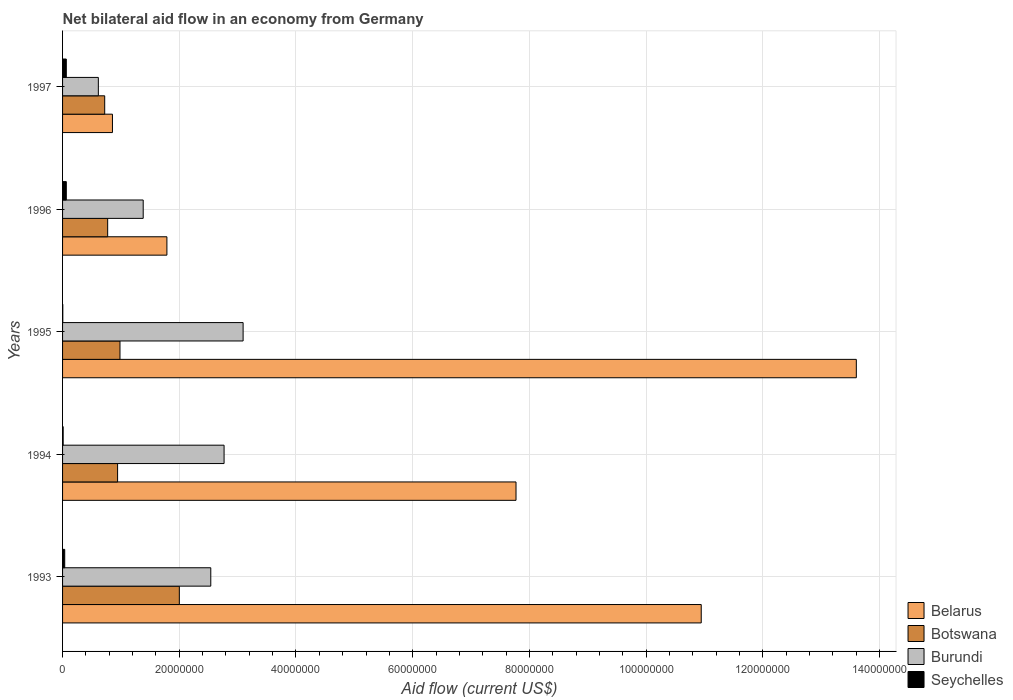How many different coloured bars are there?
Make the answer very short. 4. How many groups of bars are there?
Offer a terse response. 5. Are the number of bars on each tick of the Y-axis equal?
Offer a terse response. Yes. How many bars are there on the 5th tick from the top?
Make the answer very short. 4. In how many cases, is the number of bars for a given year not equal to the number of legend labels?
Give a very brief answer. 0. What is the net bilateral aid flow in Burundi in 1997?
Provide a short and direct response. 6.13e+06. Across all years, what is the maximum net bilateral aid flow in Belarus?
Offer a terse response. 1.36e+08. In which year was the net bilateral aid flow in Botswana minimum?
Give a very brief answer. 1997. What is the total net bilateral aid flow in Burundi in the graph?
Your answer should be compact. 1.04e+08. What is the difference between the net bilateral aid flow in Burundi in 1994 and the net bilateral aid flow in Seychelles in 1995?
Provide a succinct answer. 2.76e+07. What is the average net bilateral aid flow in Belarus per year?
Keep it short and to the point. 6.99e+07. In the year 1997, what is the difference between the net bilateral aid flow in Botswana and net bilateral aid flow in Seychelles?
Your answer should be very brief. 6.58e+06. What is the ratio of the net bilateral aid flow in Botswana in 1994 to that in 1996?
Your answer should be compact. 1.22. What is the difference between the highest and the second highest net bilateral aid flow in Belarus?
Your answer should be very brief. 2.66e+07. What is the difference between the highest and the lowest net bilateral aid flow in Botswana?
Ensure brevity in your answer.  1.28e+07. In how many years, is the net bilateral aid flow in Botswana greater than the average net bilateral aid flow in Botswana taken over all years?
Your response must be concise. 1. What does the 4th bar from the top in 1994 represents?
Give a very brief answer. Belarus. What does the 1st bar from the bottom in 1996 represents?
Give a very brief answer. Belarus. Are all the bars in the graph horizontal?
Offer a very short reply. Yes. Are the values on the major ticks of X-axis written in scientific E-notation?
Ensure brevity in your answer.  No. Does the graph contain any zero values?
Offer a very short reply. No. Does the graph contain grids?
Your answer should be very brief. Yes. How many legend labels are there?
Make the answer very short. 4. What is the title of the graph?
Your response must be concise. Net bilateral aid flow in an economy from Germany. Does "Turks and Caicos Islands" appear as one of the legend labels in the graph?
Your response must be concise. No. What is the Aid flow (current US$) of Belarus in 1993?
Your response must be concise. 1.09e+08. What is the Aid flow (current US$) in Botswana in 1993?
Provide a short and direct response. 2.00e+07. What is the Aid flow (current US$) of Burundi in 1993?
Provide a short and direct response. 2.54e+07. What is the Aid flow (current US$) in Belarus in 1994?
Provide a short and direct response. 7.77e+07. What is the Aid flow (current US$) in Botswana in 1994?
Give a very brief answer. 9.43e+06. What is the Aid flow (current US$) of Burundi in 1994?
Give a very brief answer. 2.77e+07. What is the Aid flow (current US$) of Seychelles in 1994?
Keep it short and to the point. 1.00e+05. What is the Aid flow (current US$) in Belarus in 1995?
Your answer should be compact. 1.36e+08. What is the Aid flow (current US$) of Botswana in 1995?
Provide a short and direct response. 9.84e+06. What is the Aid flow (current US$) of Burundi in 1995?
Keep it short and to the point. 3.09e+07. What is the Aid flow (current US$) of Belarus in 1996?
Keep it short and to the point. 1.79e+07. What is the Aid flow (current US$) in Botswana in 1996?
Ensure brevity in your answer.  7.73e+06. What is the Aid flow (current US$) of Burundi in 1996?
Keep it short and to the point. 1.38e+07. What is the Aid flow (current US$) of Seychelles in 1996?
Offer a terse response. 6.40e+05. What is the Aid flow (current US$) of Belarus in 1997?
Your response must be concise. 8.55e+06. What is the Aid flow (current US$) in Botswana in 1997?
Offer a terse response. 7.22e+06. What is the Aid flow (current US$) in Burundi in 1997?
Give a very brief answer. 6.13e+06. What is the Aid flow (current US$) in Seychelles in 1997?
Provide a short and direct response. 6.40e+05. Across all years, what is the maximum Aid flow (current US$) of Belarus?
Offer a terse response. 1.36e+08. Across all years, what is the maximum Aid flow (current US$) of Botswana?
Provide a short and direct response. 2.00e+07. Across all years, what is the maximum Aid flow (current US$) in Burundi?
Give a very brief answer. 3.09e+07. Across all years, what is the maximum Aid flow (current US$) of Seychelles?
Provide a succinct answer. 6.40e+05. Across all years, what is the minimum Aid flow (current US$) in Belarus?
Your answer should be compact. 8.55e+06. Across all years, what is the minimum Aid flow (current US$) of Botswana?
Your answer should be very brief. 7.22e+06. Across all years, what is the minimum Aid flow (current US$) of Burundi?
Ensure brevity in your answer.  6.13e+06. Across all years, what is the minimum Aid flow (current US$) in Seychelles?
Ensure brevity in your answer.  4.00e+04. What is the total Aid flow (current US$) in Belarus in the graph?
Give a very brief answer. 3.50e+08. What is the total Aid flow (current US$) of Botswana in the graph?
Provide a short and direct response. 5.42e+07. What is the total Aid flow (current US$) of Burundi in the graph?
Offer a very short reply. 1.04e+08. What is the total Aid flow (current US$) of Seychelles in the graph?
Your response must be concise. 1.79e+06. What is the difference between the Aid flow (current US$) of Belarus in 1993 and that in 1994?
Keep it short and to the point. 3.17e+07. What is the difference between the Aid flow (current US$) in Botswana in 1993 and that in 1994?
Offer a terse response. 1.06e+07. What is the difference between the Aid flow (current US$) in Burundi in 1993 and that in 1994?
Offer a very short reply. -2.28e+06. What is the difference between the Aid flow (current US$) in Belarus in 1993 and that in 1995?
Offer a very short reply. -2.66e+07. What is the difference between the Aid flow (current US$) of Botswana in 1993 and that in 1995?
Give a very brief answer. 1.02e+07. What is the difference between the Aid flow (current US$) in Burundi in 1993 and that in 1995?
Your response must be concise. -5.54e+06. What is the difference between the Aid flow (current US$) in Seychelles in 1993 and that in 1995?
Provide a short and direct response. 3.30e+05. What is the difference between the Aid flow (current US$) in Belarus in 1993 and that in 1996?
Keep it short and to the point. 9.16e+07. What is the difference between the Aid flow (current US$) in Botswana in 1993 and that in 1996?
Your response must be concise. 1.23e+07. What is the difference between the Aid flow (current US$) of Burundi in 1993 and that in 1996?
Your answer should be very brief. 1.16e+07. What is the difference between the Aid flow (current US$) of Seychelles in 1993 and that in 1996?
Your response must be concise. -2.70e+05. What is the difference between the Aid flow (current US$) in Belarus in 1993 and that in 1997?
Make the answer very short. 1.01e+08. What is the difference between the Aid flow (current US$) in Botswana in 1993 and that in 1997?
Keep it short and to the point. 1.28e+07. What is the difference between the Aid flow (current US$) of Burundi in 1993 and that in 1997?
Your answer should be compact. 1.93e+07. What is the difference between the Aid flow (current US$) in Seychelles in 1993 and that in 1997?
Your answer should be compact. -2.70e+05. What is the difference between the Aid flow (current US$) of Belarus in 1994 and that in 1995?
Provide a short and direct response. -5.83e+07. What is the difference between the Aid flow (current US$) in Botswana in 1994 and that in 1995?
Keep it short and to the point. -4.10e+05. What is the difference between the Aid flow (current US$) in Burundi in 1994 and that in 1995?
Provide a succinct answer. -3.26e+06. What is the difference between the Aid flow (current US$) in Belarus in 1994 and that in 1996?
Keep it short and to the point. 5.98e+07. What is the difference between the Aid flow (current US$) of Botswana in 1994 and that in 1996?
Ensure brevity in your answer.  1.70e+06. What is the difference between the Aid flow (current US$) of Burundi in 1994 and that in 1996?
Provide a short and direct response. 1.39e+07. What is the difference between the Aid flow (current US$) in Seychelles in 1994 and that in 1996?
Your answer should be compact. -5.40e+05. What is the difference between the Aid flow (current US$) of Belarus in 1994 and that in 1997?
Your answer should be very brief. 6.92e+07. What is the difference between the Aid flow (current US$) of Botswana in 1994 and that in 1997?
Offer a very short reply. 2.21e+06. What is the difference between the Aid flow (current US$) in Burundi in 1994 and that in 1997?
Your response must be concise. 2.16e+07. What is the difference between the Aid flow (current US$) in Seychelles in 1994 and that in 1997?
Give a very brief answer. -5.40e+05. What is the difference between the Aid flow (current US$) in Belarus in 1995 and that in 1996?
Your answer should be compact. 1.18e+08. What is the difference between the Aid flow (current US$) of Botswana in 1995 and that in 1996?
Give a very brief answer. 2.11e+06. What is the difference between the Aid flow (current US$) in Burundi in 1995 and that in 1996?
Provide a succinct answer. 1.71e+07. What is the difference between the Aid flow (current US$) in Seychelles in 1995 and that in 1996?
Provide a succinct answer. -6.00e+05. What is the difference between the Aid flow (current US$) of Belarus in 1995 and that in 1997?
Offer a terse response. 1.27e+08. What is the difference between the Aid flow (current US$) of Botswana in 1995 and that in 1997?
Give a very brief answer. 2.62e+06. What is the difference between the Aid flow (current US$) of Burundi in 1995 and that in 1997?
Keep it short and to the point. 2.48e+07. What is the difference between the Aid flow (current US$) in Seychelles in 1995 and that in 1997?
Offer a very short reply. -6.00e+05. What is the difference between the Aid flow (current US$) in Belarus in 1996 and that in 1997?
Your answer should be very brief. 9.33e+06. What is the difference between the Aid flow (current US$) of Botswana in 1996 and that in 1997?
Your answer should be very brief. 5.10e+05. What is the difference between the Aid flow (current US$) in Burundi in 1996 and that in 1997?
Offer a terse response. 7.69e+06. What is the difference between the Aid flow (current US$) of Seychelles in 1996 and that in 1997?
Keep it short and to the point. 0. What is the difference between the Aid flow (current US$) in Belarus in 1993 and the Aid flow (current US$) in Botswana in 1994?
Your response must be concise. 1.00e+08. What is the difference between the Aid flow (current US$) in Belarus in 1993 and the Aid flow (current US$) in Burundi in 1994?
Provide a short and direct response. 8.18e+07. What is the difference between the Aid flow (current US$) of Belarus in 1993 and the Aid flow (current US$) of Seychelles in 1994?
Your answer should be very brief. 1.09e+08. What is the difference between the Aid flow (current US$) in Botswana in 1993 and the Aid flow (current US$) in Burundi in 1994?
Keep it short and to the point. -7.67e+06. What is the difference between the Aid flow (current US$) in Botswana in 1993 and the Aid flow (current US$) in Seychelles in 1994?
Provide a succinct answer. 1.99e+07. What is the difference between the Aid flow (current US$) in Burundi in 1993 and the Aid flow (current US$) in Seychelles in 1994?
Make the answer very short. 2.53e+07. What is the difference between the Aid flow (current US$) in Belarus in 1993 and the Aid flow (current US$) in Botswana in 1995?
Give a very brief answer. 9.96e+07. What is the difference between the Aid flow (current US$) of Belarus in 1993 and the Aid flow (current US$) of Burundi in 1995?
Offer a very short reply. 7.85e+07. What is the difference between the Aid flow (current US$) of Belarus in 1993 and the Aid flow (current US$) of Seychelles in 1995?
Your answer should be compact. 1.09e+08. What is the difference between the Aid flow (current US$) of Botswana in 1993 and the Aid flow (current US$) of Burundi in 1995?
Keep it short and to the point. -1.09e+07. What is the difference between the Aid flow (current US$) of Botswana in 1993 and the Aid flow (current US$) of Seychelles in 1995?
Make the answer very short. 2.00e+07. What is the difference between the Aid flow (current US$) in Burundi in 1993 and the Aid flow (current US$) in Seychelles in 1995?
Provide a succinct answer. 2.54e+07. What is the difference between the Aid flow (current US$) in Belarus in 1993 and the Aid flow (current US$) in Botswana in 1996?
Make the answer very short. 1.02e+08. What is the difference between the Aid flow (current US$) in Belarus in 1993 and the Aid flow (current US$) in Burundi in 1996?
Offer a very short reply. 9.56e+07. What is the difference between the Aid flow (current US$) in Belarus in 1993 and the Aid flow (current US$) in Seychelles in 1996?
Give a very brief answer. 1.09e+08. What is the difference between the Aid flow (current US$) in Botswana in 1993 and the Aid flow (current US$) in Burundi in 1996?
Keep it short and to the point. 6.19e+06. What is the difference between the Aid flow (current US$) of Botswana in 1993 and the Aid flow (current US$) of Seychelles in 1996?
Your response must be concise. 1.94e+07. What is the difference between the Aid flow (current US$) in Burundi in 1993 and the Aid flow (current US$) in Seychelles in 1996?
Give a very brief answer. 2.48e+07. What is the difference between the Aid flow (current US$) of Belarus in 1993 and the Aid flow (current US$) of Botswana in 1997?
Make the answer very short. 1.02e+08. What is the difference between the Aid flow (current US$) of Belarus in 1993 and the Aid flow (current US$) of Burundi in 1997?
Your answer should be very brief. 1.03e+08. What is the difference between the Aid flow (current US$) in Belarus in 1993 and the Aid flow (current US$) in Seychelles in 1997?
Offer a very short reply. 1.09e+08. What is the difference between the Aid flow (current US$) in Botswana in 1993 and the Aid flow (current US$) in Burundi in 1997?
Your answer should be very brief. 1.39e+07. What is the difference between the Aid flow (current US$) of Botswana in 1993 and the Aid flow (current US$) of Seychelles in 1997?
Your answer should be compact. 1.94e+07. What is the difference between the Aid flow (current US$) of Burundi in 1993 and the Aid flow (current US$) of Seychelles in 1997?
Keep it short and to the point. 2.48e+07. What is the difference between the Aid flow (current US$) of Belarus in 1994 and the Aid flow (current US$) of Botswana in 1995?
Provide a short and direct response. 6.79e+07. What is the difference between the Aid flow (current US$) in Belarus in 1994 and the Aid flow (current US$) in Burundi in 1995?
Your answer should be compact. 4.68e+07. What is the difference between the Aid flow (current US$) in Belarus in 1994 and the Aid flow (current US$) in Seychelles in 1995?
Provide a short and direct response. 7.77e+07. What is the difference between the Aid flow (current US$) of Botswana in 1994 and the Aid flow (current US$) of Burundi in 1995?
Offer a terse response. -2.15e+07. What is the difference between the Aid flow (current US$) of Botswana in 1994 and the Aid flow (current US$) of Seychelles in 1995?
Provide a short and direct response. 9.39e+06. What is the difference between the Aid flow (current US$) in Burundi in 1994 and the Aid flow (current US$) in Seychelles in 1995?
Keep it short and to the point. 2.76e+07. What is the difference between the Aid flow (current US$) in Belarus in 1994 and the Aid flow (current US$) in Botswana in 1996?
Your answer should be compact. 7.00e+07. What is the difference between the Aid flow (current US$) in Belarus in 1994 and the Aid flow (current US$) in Burundi in 1996?
Your answer should be compact. 6.39e+07. What is the difference between the Aid flow (current US$) of Belarus in 1994 and the Aid flow (current US$) of Seychelles in 1996?
Offer a terse response. 7.71e+07. What is the difference between the Aid flow (current US$) of Botswana in 1994 and the Aid flow (current US$) of Burundi in 1996?
Ensure brevity in your answer.  -4.39e+06. What is the difference between the Aid flow (current US$) in Botswana in 1994 and the Aid flow (current US$) in Seychelles in 1996?
Keep it short and to the point. 8.79e+06. What is the difference between the Aid flow (current US$) of Burundi in 1994 and the Aid flow (current US$) of Seychelles in 1996?
Give a very brief answer. 2.70e+07. What is the difference between the Aid flow (current US$) of Belarus in 1994 and the Aid flow (current US$) of Botswana in 1997?
Provide a short and direct response. 7.05e+07. What is the difference between the Aid flow (current US$) in Belarus in 1994 and the Aid flow (current US$) in Burundi in 1997?
Your answer should be compact. 7.16e+07. What is the difference between the Aid flow (current US$) in Belarus in 1994 and the Aid flow (current US$) in Seychelles in 1997?
Offer a terse response. 7.71e+07. What is the difference between the Aid flow (current US$) of Botswana in 1994 and the Aid flow (current US$) of Burundi in 1997?
Your response must be concise. 3.30e+06. What is the difference between the Aid flow (current US$) of Botswana in 1994 and the Aid flow (current US$) of Seychelles in 1997?
Offer a very short reply. 8.79e+06. What is the difference between the Aid flow (current US$) of Burundi in 1994 and the Aid flow (current US$) of Seychelles in 1997?
Provide a short and direct response. 2.70e+07. What is the difference between the Aid flow (current US$) in Belarus in 1995 and the Aid flow (current US$) in Botswana in 1996?
Ensure brevity in your answer.  1.28e+08. What is the difference between the Aid flow (current US$) of Belarus in 1995 and the Aid flow (current US$) of Burundi in 1996?
Provide a succinct answer. 1.22e+08. What is the difference between the Aid flow (current US$) of Belarus in 1995 and the Aid flow (current US$) of Seychelles in 1996?
Offer a terse response. 1.35e+08. What is the difference between the Aid flow (current US$) of Botswana in 1995 and the Aid flow (current US$) of Burundi in 1996?
Offer a terse response. -3.98e+06. What is the difference between the Aid flow (current US$) in Botswana in 1995 and the Aid flow (current US$) in Seychelles in 1996?
Provide a succinct answer. 9.20e+06. What is the difference between the Aid flow (current US$) in Burundi in 1995 and the Aid flow (current US$) in Seychelles in 1996?
Your response must be concise. 3.03e+07. What is the difference between the Aid flow (current US$) in Belarus in 1995 and the Aid flow (current US$) in Botswana in 1997?
Ensure brevity in your answer.  1.29e+08. What is the difference between the Aid flow (current US$) of Belarus in 1995 and the Aid flow (current US$) of Burundi in 1997?
Offer a terse response. 1.30e+08. What is the difference between the Aid flow (current US$) of Belarus in 1995 and the Aid flow (current US$) of Seychelles in 1997?
Your answer should be very brief. 1.35e+08. What is the difference between the Aid flow (current US$) of Botswana in 1995 and the Aid flow (current US$) of Burundi in 1997?
Ensure brevity in your answer.  3.71e+06. What is the difference between the Aid flow (current US$) of Botswana in 1995 and the Aid flow (current US$) of Seychelles in 1997?
Offer a very short reply. 9.20e+06. What is the difference between the Aid flow (current US$) in Burundi in 1995 and the Aid flow (current US$) in Seychelles in 1997?
Give a very brief answer. 3.03e+07. What is the difference between the Aid flow (current US$) of Belarus in 1996 and the Aid flow (current US$) of Botswana in 1997?
Your answer should be very brief. 1.07e+07. What is the difference between the Aid flow (current US$) in Belarus in 1996 and the Aid flow (current US$) in Burundi in 1997?
Offer a very short reply. 1.18e+07. What is the difference between the Aid flow (current US$) of Belarus in 1996 and the Aid flow (current US$) of Seychelles in 1997?
Offer a very short reply. 1.72e+07. What is the difference between the Aid flow (current US$) in Botswana in 1996 and the Aid flow (current US$) in Burundi in 1997?
Keep it short and to the point. 1.60e+06. What is the difference between the Aid flow (current US$) in Botswana in 1996 and the Aid flow (current US$) in Seychelles in 1997?
Offer a very short reply. 7.09e+06. What is the difference between the Aid flow (current US$) of Burundi in 1996 and the Aid flow (current US$) of Seychelles in 1997?
Make the answer very short. 1.32e+07. What is the average Aid flow (current US$) of Belarus per year?
Give a very brief answer. 6.99e+07. What is the average Aid flow (current US$) of Botswana per year?
Your answer should be compact. 1.08e+07. What is the average Aid flow (current US$) of Burundi per year?
Make the answer very short. 2.08e+07. What is the average Aid flow (current US$) of Seychelles per year?
Your answer should be very brief. 3.58e+05. In the year 1993, what is the difference between the Aid flow (current US$) of Belarus and Aid flow (current US$) of Botswana?
Provide a succinct answer. 8.94e+07. In the year 1993, what is the difference between the Aid flow (current US$) of Belarus and Aid flow (current US$) of Burundi?
Offer a terse response. 8.40e+07. In the year 1993, what is the difference between the Aid flow (current US$) of Belarus and Aid flow (current US$) of Seychelles?
Your answer should be compact. 1.09e+08. In the year 1993, what is the difference between the Aid flow (current US$) of Botswana and Aid flow (current US$) of Burundi?
Keep it short and to the point. -5.39e+06. In the year 1993, what is the difference between the Aid flow (current US$) of Botswana and Aid flow (current US$) of Seychelles?
Make the answer very short. 1.96e+07. In the year 1993, what is the difference between the Aid flow (current US$) in Burundi and Aid flow (current US$) in Seychelles?
Make the answer very short. 2.50e+07. In the year 1994, what is the difference between the Aid flow (current US$) of Belarus and Aid flow (current US$) of Botswana?
Ensure brevity in your answer.  6.83e+07. In the year 1994, what is the difference between the Aid flow (current US$) in Belarus and Aid flow (current US$) in Burundi?
Keep it short and to the point. 5.00e+07. In the year 1994, what is the difference between the Aid flow (current US$) of Belarus and Aid flow (current US$) of Seychelles?
Keep it short and to the point. 7.76e+07. In the year 1994, what is the difference between the Aid flow (current US$) in Botswana and Aid flow (current US$) in Burundi?
Your response must be concise. -1.82e+07. In the year 1994, what is the difference between the Aid flow (current US$) in Botswana and Aid flow (current US$) in Seychelles?
Your answer should be very brief. 9.33e+06. In the year 1994, what is the difference between the Aid flow (current US$) in Burundi and Aid flow (current US$) in Seychelles?
Provide a short and direct response. 2.76e+07. In the year 1995, what is the difference between the Aid flow (current US$) of Belarus and Aid flow (current US$) of Botswana?
Offer a very short reply. 1.26e+08. In the year 1995, what is the difference between the Aid flow (current US$) in Belarus and Aid flow (current US$) in Burundi?
Keep it short and to the point. 1.05e+08. In the year 1995, what is the difference between the Aid flow (current US$) in Belarus and Aid flow (current US$) in Seychelles?
Offer a very short reply. 1.36e+08. In the year 1995, what is the difference between the Aid flow (current US$) of Botswana and Aid flow (current US$) of Burundi?
Give a very brief answer. -2.11e+07. In the year 1995, what is the difference between the Aid flow (current US$) of Botswana and Aid flow (current US$) of Seychelles?
Your response must be concise. 9.80e+06. In the year 1995, what is the difference between the Aid flow (current US$) in Burundi and Aid flow (current US$) in Seychelles?
Provide a short and direct response. 3.09e+07. In the year 1996, what is the difference between the Aid flow (current US$) of Belarus and Aid flow (current US$) of Botswana?
Give a very brief answer. 1.02e+07. In the year 1996, what is the difference between the Aid flow (current US$) of Belarus and Aid flow (current US$) of Burundi?
Give a very brief answer. 4.06e+06. In the year 1996, what is the difference between the Aid flow (current US$) of Belarus and Aid flow (current US$) of Seychelles?
Offer a very short reply. 1.72e+07. In the year 1996, what is the difference between the Aid flow (current US$) in Botswana and Aid flow (current US$) in Burundi?
Keep it short and to the point. -6.09e+06. In the year 1996, what is the difference between the Aid flow (current US$) of Botswana and Aid flow (current US$) of Seychelles?
Give a very brief answer. 7.09e+06. In the year 1996, what is the difference between the Aid flow (current US$) of Burundi and Aid flow (current US$) of Seychelles?
Offer a terse response. 1.32e+07. In the year 1997, what is the difference between the Aid flow (current US$) of Belarus and Aid flow (current US$) of Botswana?
Your answer should be compact. 1.33e+06. In the year 1997, what is the difference between the Aid flow (current US$) of Belarus and Aid flow (current US$) of Burundi?
Provide a short and direct response. 2.42e+06. In the year 1997, what is the difference between the Aid flow (current US$) of Belarus and Aid flow (current US$) of Seychelles?
Make the answer very short. 7.91e+06. In the year 1997, what is the difference between the Aid flow (current US$) of Botswana and Aid flow (current US$) of Burundi?
Provide a succinct answer. 1.09e+06. In the year 1997, what is the difference between the Aid flow (current US$) in Botswana and Aid flow (current US$) in Seychelles?
Offer a very short reply. 6.58e+06. In the year 1997, what is the difference between the Aid flow (current US$) of Burundi and Aid flow (current US$) of Seychelles?
Your answer should be compact. 5.49e+06. What is the ratio of the Aid flow (current US$) of Belarus in 1993 to that in 1994?
Provide a succinct answer. 1.41. What is the ratio of the Aid flow (current US$) of Botswana in 1993 to that in 1994?
Ensure brevity in your answer.  2.12. What is the ratio of the Aid flow (current US$) of Burundi in 1993 to that in 1994?
Offer a terse response. 0.92. What is the ratio of the Aid flow (current US$) in Seychelles in 1993 to that in 1994?
Provide a short and direct response. 3.7. What is the ratio of the Aid flow (current US$) in Belarus in 1993 to that in 1995?
Your response must be concise. 0.8. What is the ratio of the Aid flow (current US$) in Botswana in 1993 to that in 1995?
Your answer should be very brief. 2.03. What is the ratio of the Aid flow (current US$) of Burundi in 1993 to that in 1995?
Provide a succinct answer. 0.82. What is the ratio of the Aid flow (current US$) of Seychelles in 1993 to that in 1995?
Your response must be concise. 9.25. What is the ratio of the Aid flow (current US$) of Belarus in 1993 to that in 1996?
Make the answer very short. 6.12. What is the ratio of the Aid flow (current US$) in Botswana in 1993 to that in 1996?
Offer a very short reply. 2.59. What is the ratio of the Aid flow (current US$) in Burundi in 1993 to that in 1996?
Provide a succinct answer. 1.84. What is the ratio of the Aid flow (current US$) in Seychelles in 1993 to that in 1996?
Make the answer very short. 0.58. What is the ratio of the Aid flow (current US$) in Belarus in 1993 to that in 1997?
Offer a very short reply. 12.8. What is the ratio of the Aid flow (current US$) in Botswana in 1993 to that in 1997?
Provide a short and direct response. 2.77. What is the ratio of the Aid flow (current US$) of Burundi in 1993 to that in 1997?
Give a very brief answer. 4.14. What is the ratio of the Aid flow (current US$) of Seychelles in 1993 to that in 1997?
Keep it short and to the point. 0.58. What is the ratio of the Aid flow (current US$) in Belarus in 1994 to that in 1995?
Provide a succinct answer. 0.57. What is the ratio of the Aid flow (current US$) in Botswana in 1994 to that in 1995?
Your answer should be compact. 0.96. What is the ratio of the Aid flow (current US$) in Burundi in 1994 to that in 1995?
Your answer should be very brief. 0.89. What is the ratio of the Aid flow (current US$) in Belarus in 1994 to that in 1996?
Offer a terse response. 4.35. What is the ratio of the Aid flow (current US$) in Botswana in 1994 to that in 1996?
Your answer should be very brief. 1.22. What is the ratio of the Aid flow (current US$) of Burundi in 1994 to that in 1996?
Your answer should be compact. 2. What is the ratio of the Aid flow (current US$) in Seychelles in 1994 to that in 1996?
Keep it short and to the point. 0.16. What is the ratio of the Aid flow (current US$) of Belarus in 1994 to that in 1997?
Provide a succinct answer. 9.09. What is the ratio of the Aid flow (current US$) of Botswana in 1994 to that in 1997?
Provide a succinct answer. 1.31. What is the ratio of the Aid flow (current US$) of Burundi in 1994 to that in 1997?
Provide a succinct answer. 4.52. What is the ratio of the Aid flow (current US$) in Seychelles in 1994 to that in 1997?
Ensure brevity in your answer.  0.16. What is the ratio of the Aid flow (current US$) of Belarus in 1995 to that in 1996?
Ensure brevity in your answer.  7.61. What is the ratio of the Aid flow (current US$) in Botswana in 1995 to that in 1996?
Make the answer very short. 1.27. What is the ratio of the Aid flow (current US$) of Burundi in 1995 to that in 1996?
Offer a very short reply. 2.24. What is the ratio of the Aid flow (current US$) of Seychelles in 1995 to that in 1996?
Your answer should be very brief. 0.06. What is the ratio of the Aid flow (current US$) in Belarus in 1995 to that in 1997?
Your response must be concise. 15.91. What is the ratio of the Aid flow (current US$) in Botswana in 1995 to that in 1997?
Offer a very short reply. 1.36. What is the ratio of the Aid flow (current US$) in Burundi in 1995 to that in 1997?
Your answer should be compact. 5.05. What is the ratio of the Aid flow (current US$) in Seychelles in 1995 to that in 1997?
Provide a succinct answer. 0.06. What is the ratio of the Aid flow (current US$) in Belarus in 1996 to that in 1997?
Your answer should be compact. 2.09. What is the ratio of the Aid flow (current US$) in Botswana in 1996 to that in 1997?
Keep it short and to the point. 1.07. What is the ratio of the Aid flow (current US$) of Burundi in 1996 to that in 1997?
Give a very brief answer. 2.25. What is the difference between the highest and the second highest Aid flow (current US$) of Belarus?
Offer a terse response. 2.66e+07. What is the difference between the highest and the second highest Aid flow (current US$) of Botswana?
Offer a terse response. 1.02e+07. What is the difference between the highest and the second highest Aid flow (current US$) in Burundi?
Offer a terse response. 3.26e+06. What is the difference between the highest and the lowest Aid flow (current US$) in Belarus?
Provide a succinct answer. 1.27e+08. What is the difference between the highest and the lowest Aid flow (current US$) in Botswana?
Keep it short and to the point. 1.28e+07. What is the difference between the highest and the lowest Aid flow (current US$) of Burundi?
Provide a succinct answer. 2.48e+07. 